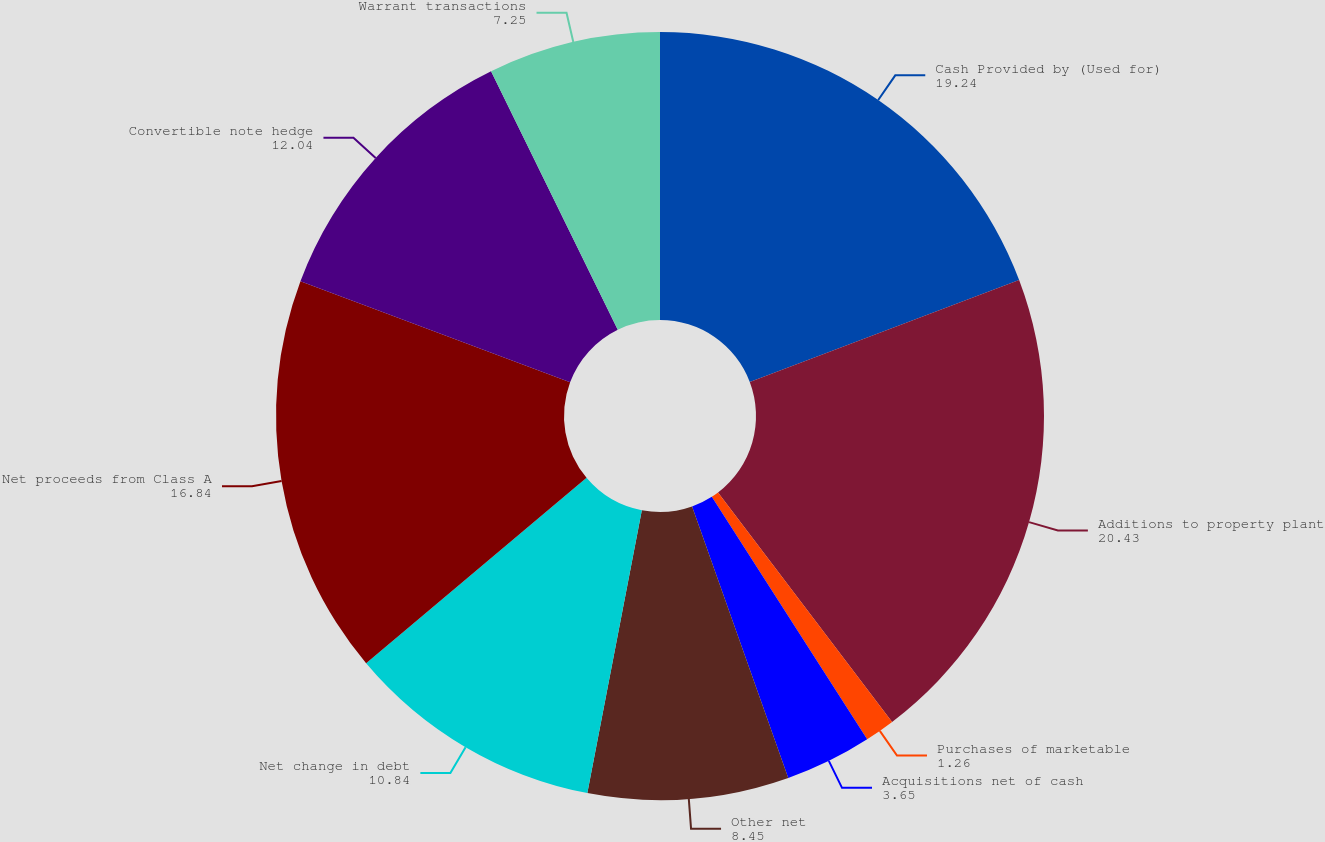Convert chart. <chart><loc_0><loc_0><loc_500><loc_500><pie_chart><fcel>Cash Provided by (Used for)<fcel>Additions to property plant<fcel>Purchases of marketable<fcel>Acquisitions net of cash<fcel>Other net<fcel>Net change in debt<fcel>Net proceeds from Class A<fcel>Convertible note hedge<fcel>Warrant transactions<nl><fcel>19.24%<fcel>20.43%<fcel>1.26%<fcel>3.65%<fcel>8.45%<fcel>10.84%<fcel>16.84%<fcel>12.04%<fcel>7.25%<nl></chart> 